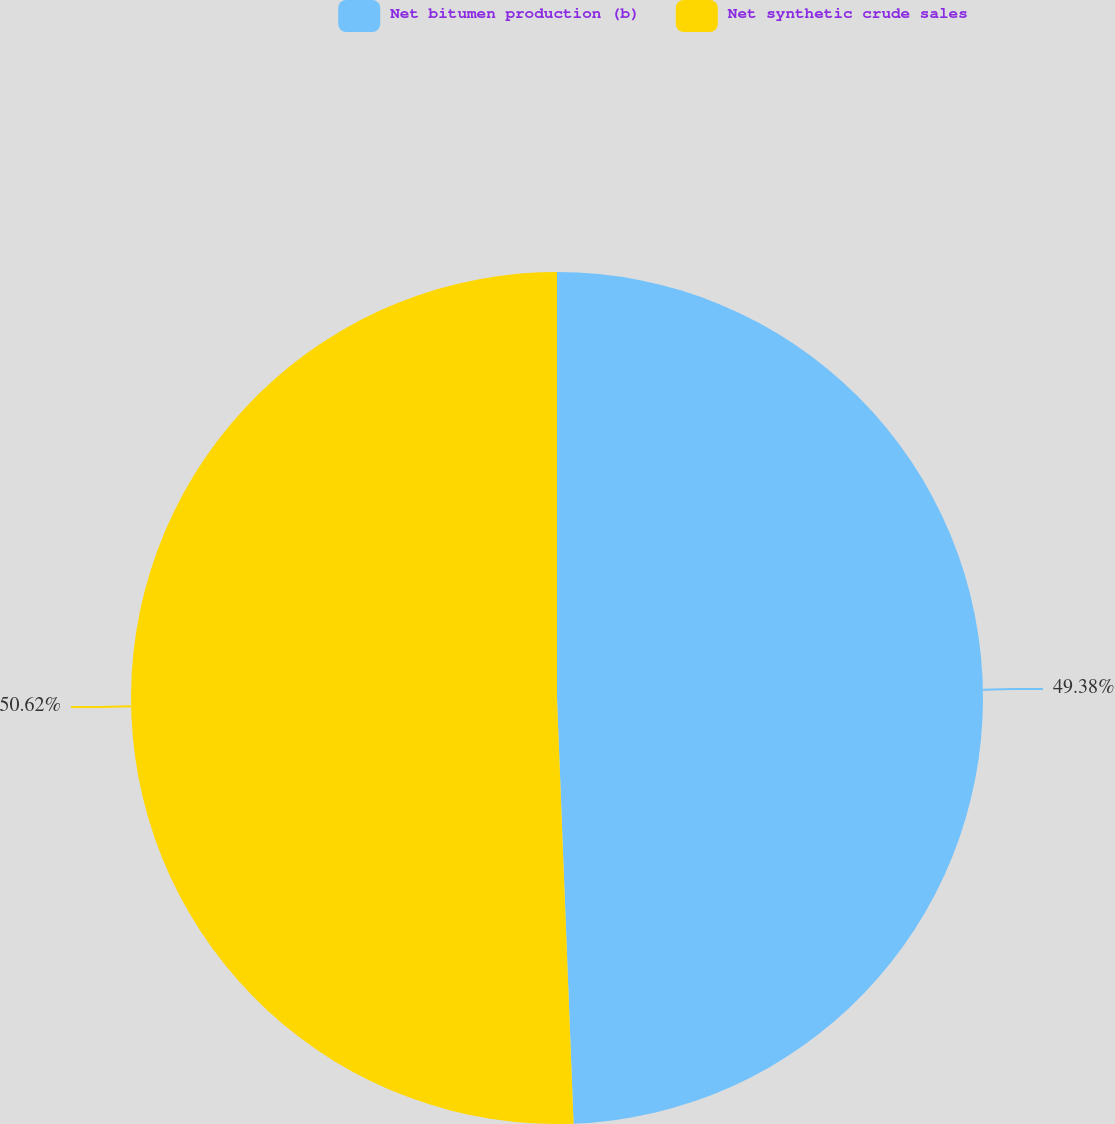Convert chart. <chart><loc_0><loc_0><loc_500><loc_500><pie_chart><fcel>Net bitumen production (b)<fcel>Net synthetic crude sales<nl><fcel>49.38%<fcel>50.62%<nl></chart> 